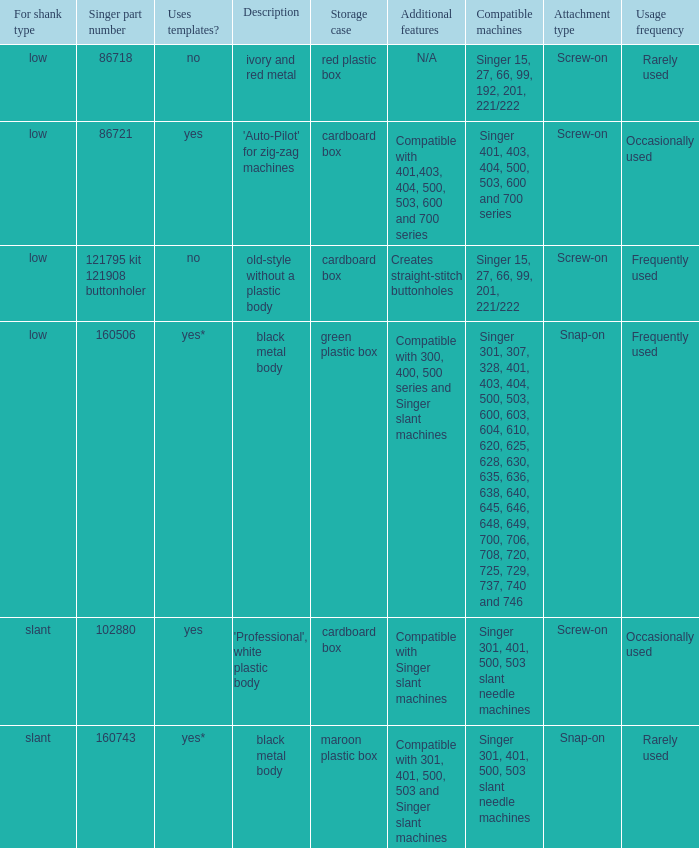What's the storage case of the buttonholer described as ivory and red metal? Red plastic box. Write the full table. {'header': ['For shank type', 'Singer part number', 'Uses templates?', 'Description', 'Storage case', 'Additional features', 'Compatible machines', 'Attachment type', 'Usage frequency'], 'rows': [['low', '86718', 'no', 'ivory and red metal', 'red plastic box', 'N/A', 'Singer 15, 27, 66, 99, 192, 201, 221/222', 'Screw-on', 'Rarely used'], ['low', '86721', 'yes', "'Auto-Pilot' for zig-zag machines", 'cardboard box', 'Compatible with 401,403, 404, 500, 503, 600 and 700 series', 'Singer 401, 403, 404, 500, 503, 600 and 700 series', 'Screw-on', 'Occasionally used '], ['low', '121795 kit 121908 buttonholer', 'no', 'old-style without a plastic body', 'cardboard box', 'Creates straight-stitch buttonholes', 'Singer 15, 27, 66, 99, 201, 221/222', 'Screw-on', 'Frequently used '], ['low', '160506', 'yes*', 'black metal body', 'green plastic box', 'Compatible with 300, 400, 500 series and Singer slant machines', 'Singer 301, 307, 328, 401, 403, 404, 500, 503, 600, 603, 604, 610, 620, 625, 628, 630, 635, 636, 638, 640, 645, 646, 648, 649, 700, 706, 708, 720, 725, 729, 737, 740 and 746', 'Snap-on', 'Frequently used'], ['slant', '102880', 'yes', "'Professional', white plastic body", 'cardboard box', 'Compatible with Singer slant machines', 'Singer 301, 401, 500, 503 slant needle machines', 'Screw-on', 'Occasionally used '], ['slant', '160743', 'yes*', 'black metal body', 'maroon plastic box', 'Compatible with 301, 401, 500, 503 and Singer slant machines', 'Singer 301, 401, 500, 503 slant needle machines', 'Snap-on', 'Rarely used']]} 